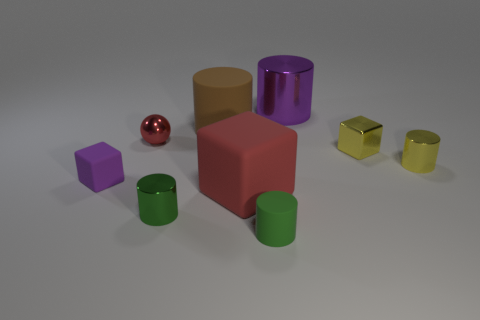What number of purple objects are small metallic cubes or metal balls?
Make the answer very short. 0. Are there fewer big metallic cylinders that are on the left side of the purple matte block than red blocks that are on the left side of the red rubber thing?
Ensure brevity in your answer.  No. Are there any rubber blocks that have the same size as the brown object?
Provide a short and direct response. Yes. There is a green object that is to the left of the red rubber object; is its size the same as the tiny purple block?
Your answer should be compact. Yes. Is the number of blue matte cylinders greater than the number of metal cubes?
Your response must be concise. No. Is there a large red thing of the same shape as the purple rubber object?
Ensure brevity in your answer.  Yes. What shape is the rubber thing behind the red ball?
Your answer should be very brief. Cylinder. How many yellow cylinders are behind the tiny metallic cylinder that is left of the purple object to the right of the tiny green rubber cylinder?
Your answer should be compact. 1. Does the shiny cylinder to the left of the purple shiny cylinder have the same color as the small matte cylinder?
Your response must be concise. Yes. How many other objects are the same shape as the purple rubber object?
Provide a short and direct response. 2. 